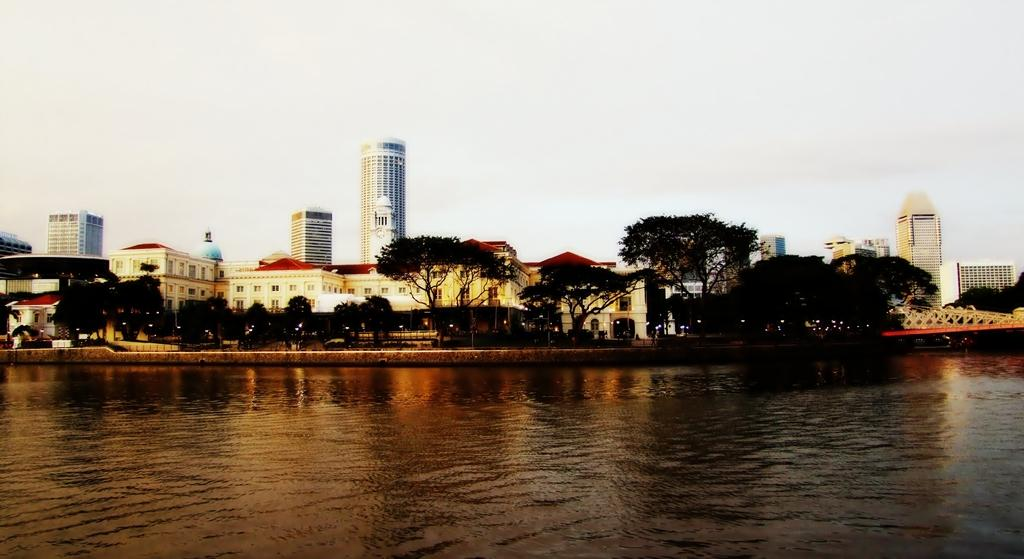What is visible in the image? Water is visible in the image. What can be seen in the background of the image? There are trees and buildings in the background of the image. How many scales can be seen on the fish in the image? There is no fish present in the image, so there are no scales to count. What type of flowers are growing near the water in the image? There are no flowers visible in the image. 